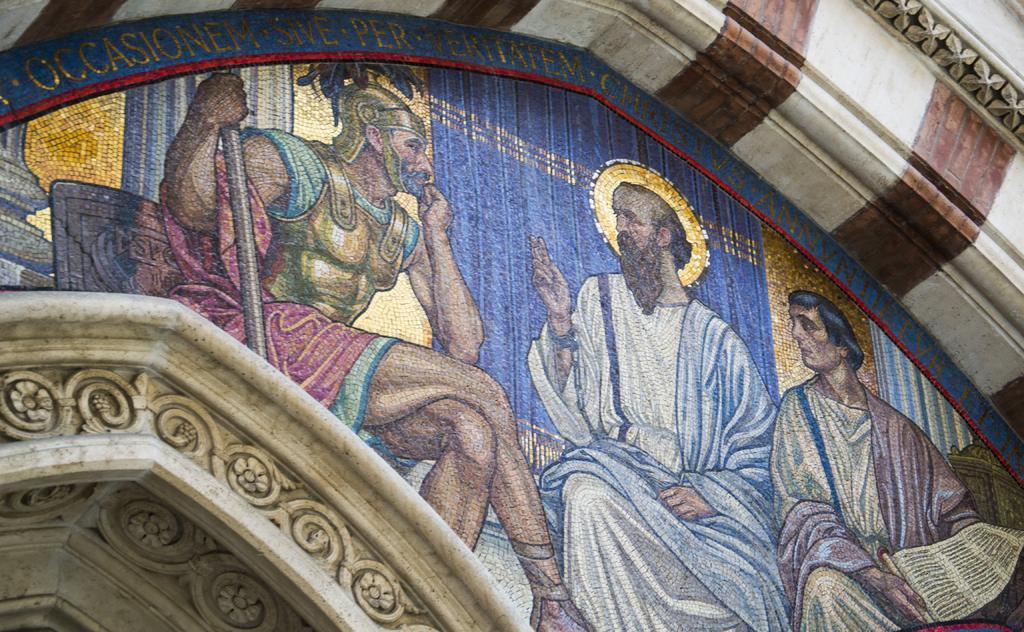Could you give a brief overview of what you see in this image? In this image we can see a painting on a building, there are three persons sitting. 